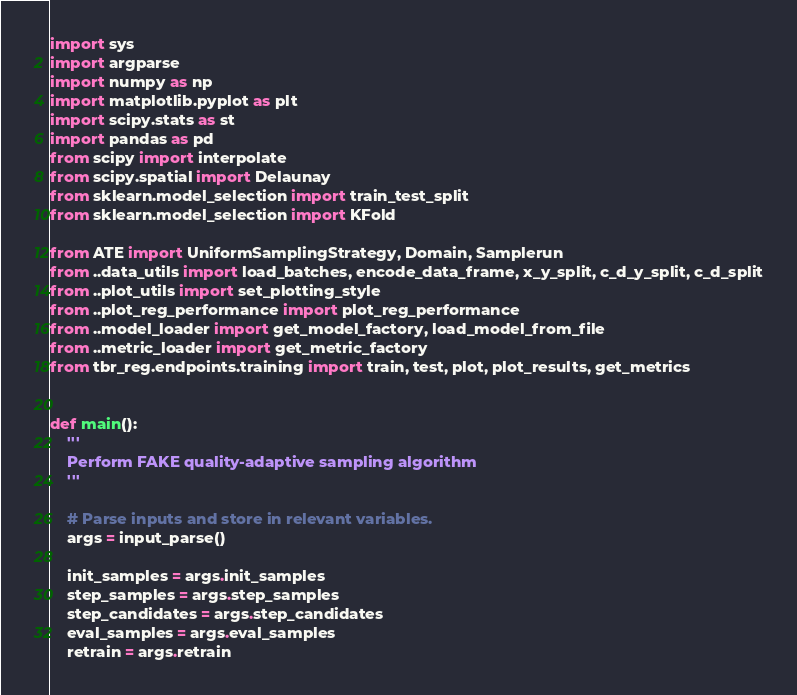Convert code to text. <code><loc_0><loc_0><loc_500><loc_500><_Python_>import sys
import argparse
import numpy as np
import matplotlib.pyplot as plt
import scipy.stats as st
import pandas as pd
from scipy import interpolate
from scipy.spatial import Delaunay
from sklearn.model_selection import train_test_split
from sklearn.model_selection import KFold

from ATE import UniformSamplingStrategy, Domain, Samplerun
from ..data_utils import load_batches, encode_data_frame, x_y_split, c_d_y_split, c_d_split
from ..plot_utils import set_plotting_style
from ..plot_reg_performance import plot_reg_performance
from ..model_loader import get_model_factory, load_model_from_file
from ..metric_loader import get_metric_factory
from tbr_reg.endpoints.training import train, test, plot, plot_results, get_metrics


def main():
    '''
    Perform FAKE quality-adaptive sampling algorithm
    '''
    
    # Parse inputs and store in relevant variables.
    args = input_parse()
    
    init_samples = args.init_samples
    step_samples = args.step_samples
    step_candidates = args.step_candidates
    eval_samples = args.eval_samples
    retrain = args.retrain</code> 